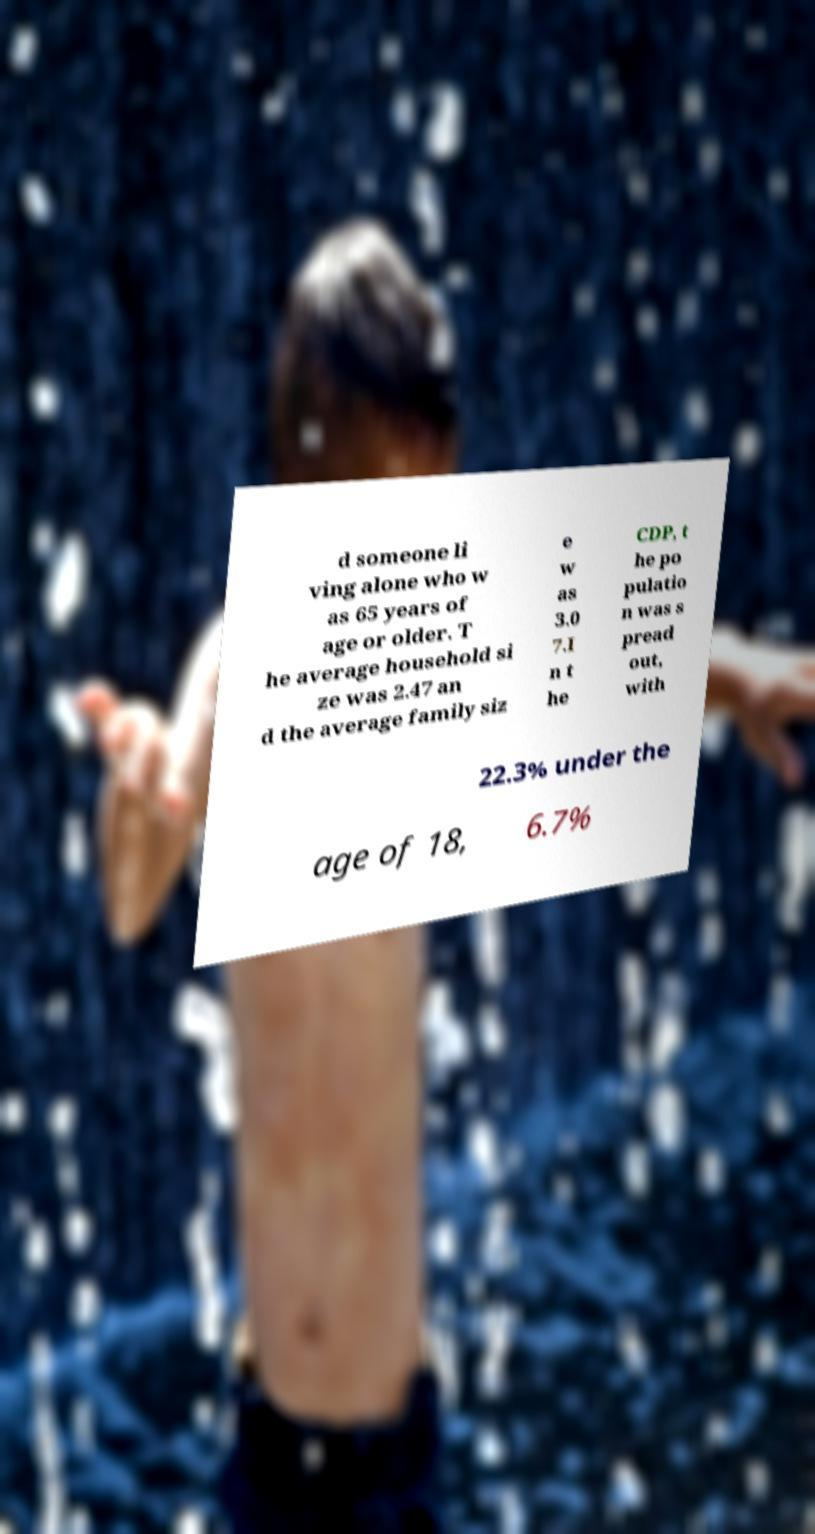Could you assist in decoding the text presented in this image and type it out clearly? d someone li ving alone who w as 65 years of age or older. T he average household si ze was 2.47 an d the average family siz e w as 3.0 7.I n t he CDP, t he po pulatio n was s pread out, with 22.3% under the age of 18, 6.7% 